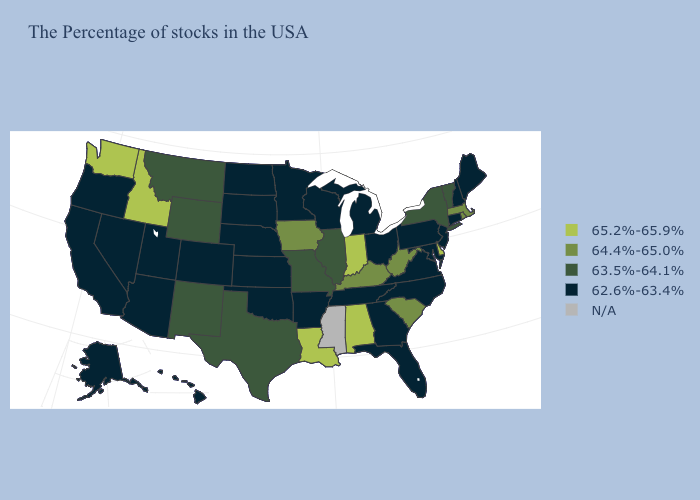What is the value of New Jersey?
Quick response, please. 62.6%-63.4%. Name the states that have a value in the range 65.2%-65.9%?
Give a very brief answer. Delaware, Indiana, Alabama, Louisiana, Idaho, Washington. Name the states that have a value in the range 64.4%-65.0%?
Concise answer only. Massachusetts, Rhode Island, South Carolina, West Virginia, Kentucky, Iowa. What is the highest value in states that border West Virginia?
Be succinct. 64.4%-65.0%. Does Rhode Island have the highest value in the USA?
Keep it brief. No. What is the highest value in states that border Texas?
Keep it brief. 65.2%-65.9%. Does Arizona have the lowest value in the West?
Concise answer only. Yes. What is the lowest value in states that border Florida?
Short answer required. 62.6%-63.4%. Name the states that have a value in the range 65.2%-65.9%?
Give a very brief answer. Delaware, Indiana, Alabama, Louisiana, Idaho, Washington. What is the highest value in states that border California?
Quick response, please. 62.6%-63.4%. Does the first symbol in the legend represent the smallest category?
Keep it brief. No. Does Iowa have the highest value in the MidWest?
Write a very short answer. No. Among the states that border Kansas , which have the lowest value?
Give a very brief answer. Nebraska, Oklahoma, Colorado. What is the value of Virginia?
Quick response, please. 62.6%-63.4%. Which states have the lowest value in the USA?
Be succinct. Maine, New Hampshire, Connecticut, New Jersey, Maryland, Pennsylvania, Virginia, North Carolina, Ohio, Florida, Georgia, Michigan, Tennessee, Wisconsin, Arkansas, Minnesota, Kansas, Nebraska, Oklahoma, South Dakota, North Dakota, Colorado, Utah, Arizona, Nevada, California, Oregon, Alaska, Hawaii. 